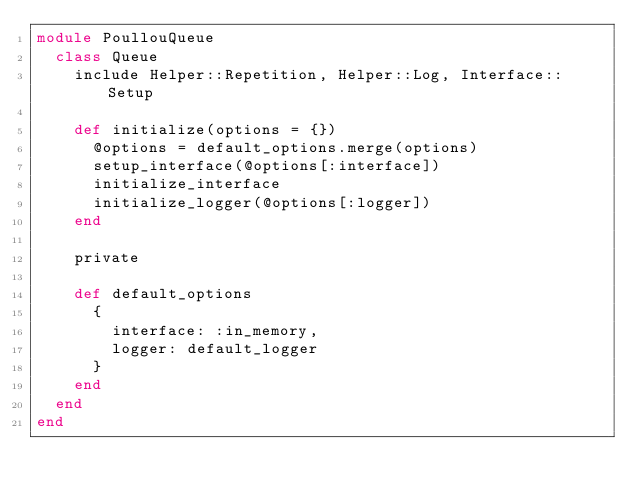<code> <loc_0><loc_0><loc_500><loc_500><_Ruby_>module PoullouQueue
  class Queue
    include Helper::Repetition, Helper::Log, Interface::Setup

    def initialize(options = {})
      @options = default_options.merge(options)
      setup_interface(@options[:interface])
      initialize_interface
      initialize_logger(@options[:logger])
    end

    private

    def default_options
      {
        interface: :in_memory,
        logger: default_logger
      }
    end
  end
end
</code> 